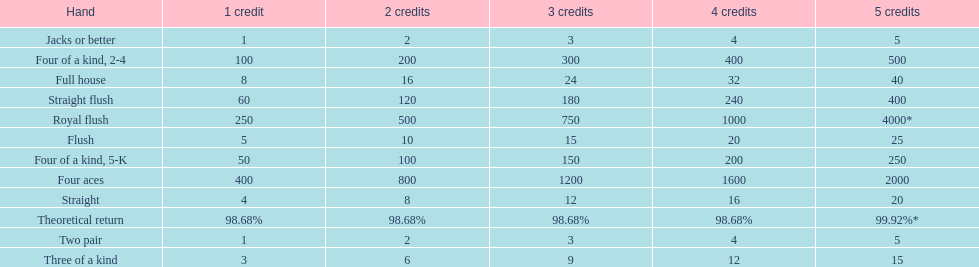Which hand is the top hand in the card game super aces? Royal flush. 